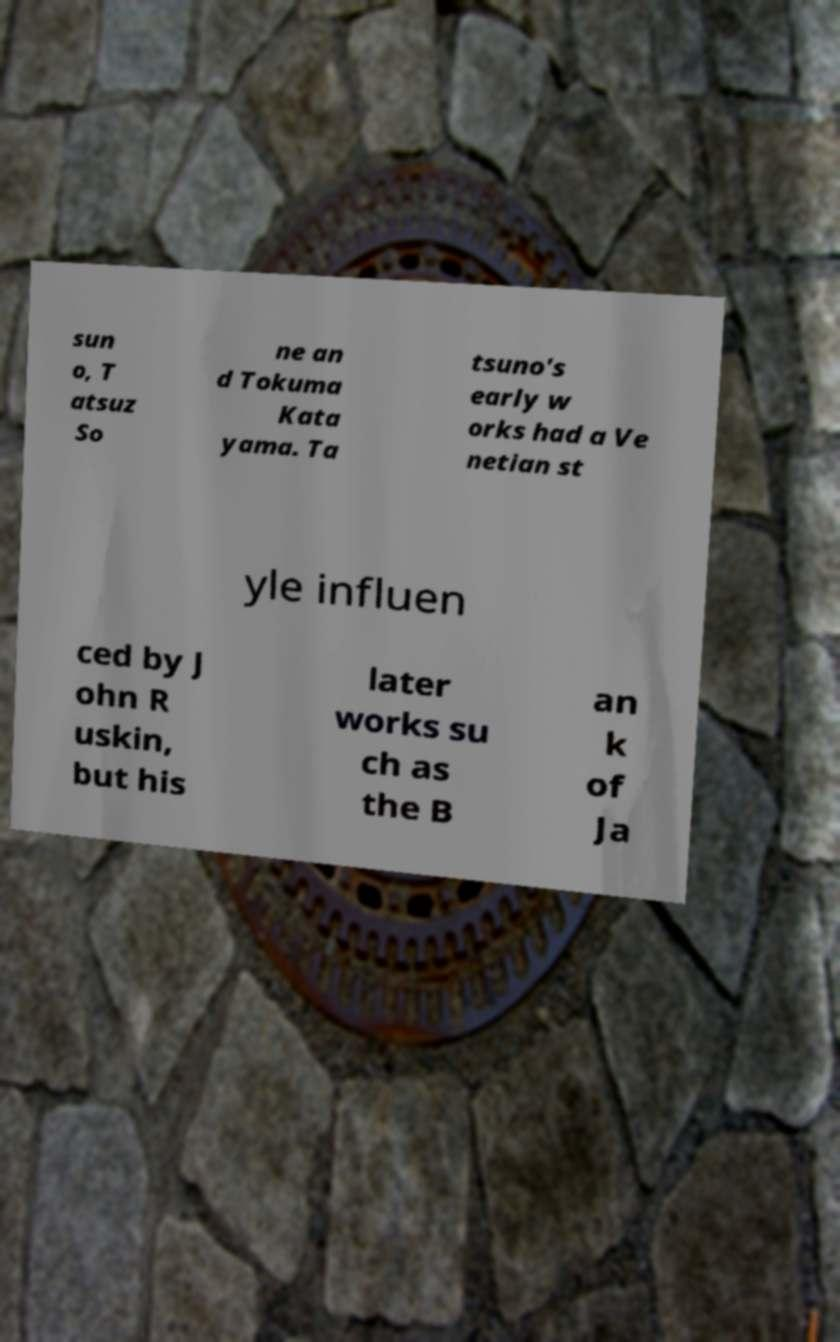What messages or text are displayed in this image? I need them in a readable, typed format. sun o, T atsuz So ne an d Tokuma Kata yama. Ta tsuno's early w orks had a Ve netian st yle influen ced by J ohn R uskin, but his later works su ch as the B an k of Ja 